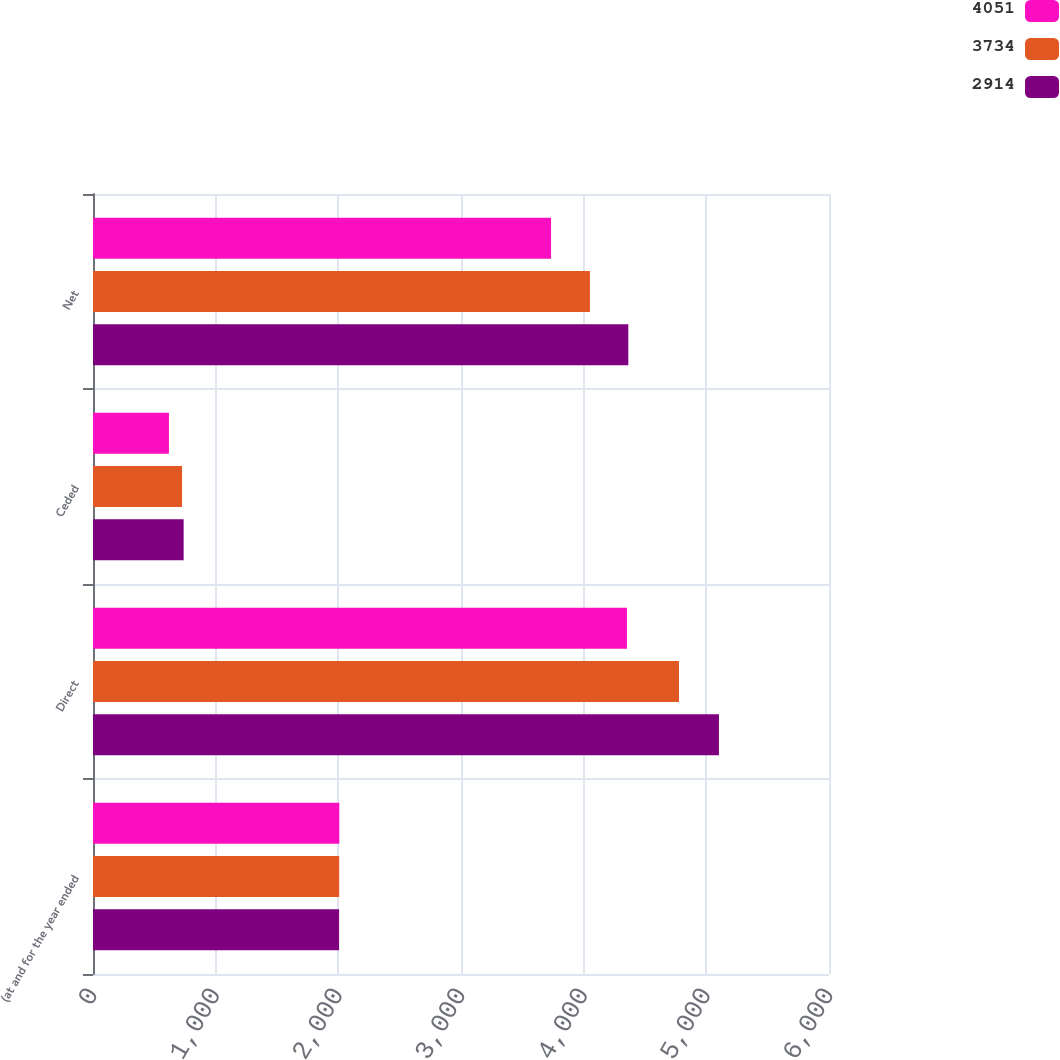Convert chart. <chart><loc_0><loc_0><loc_500><loc_500><stacked_bar_chart><ecel><fcel>(at and for the year ended<fcel>Direct<fcel>Ceded<fcel>Net<nl><fcel>4051<fcel>2008<fcel>4353<fcel>619<fcel>3734<nl><fcel>3734<fcel>2007<fcel>4777<fcel>726<fcel>4051<nl><fcel>2914<fcel>2006<fcel>5103<fcel>739<fcel>4364<nl></chart> 